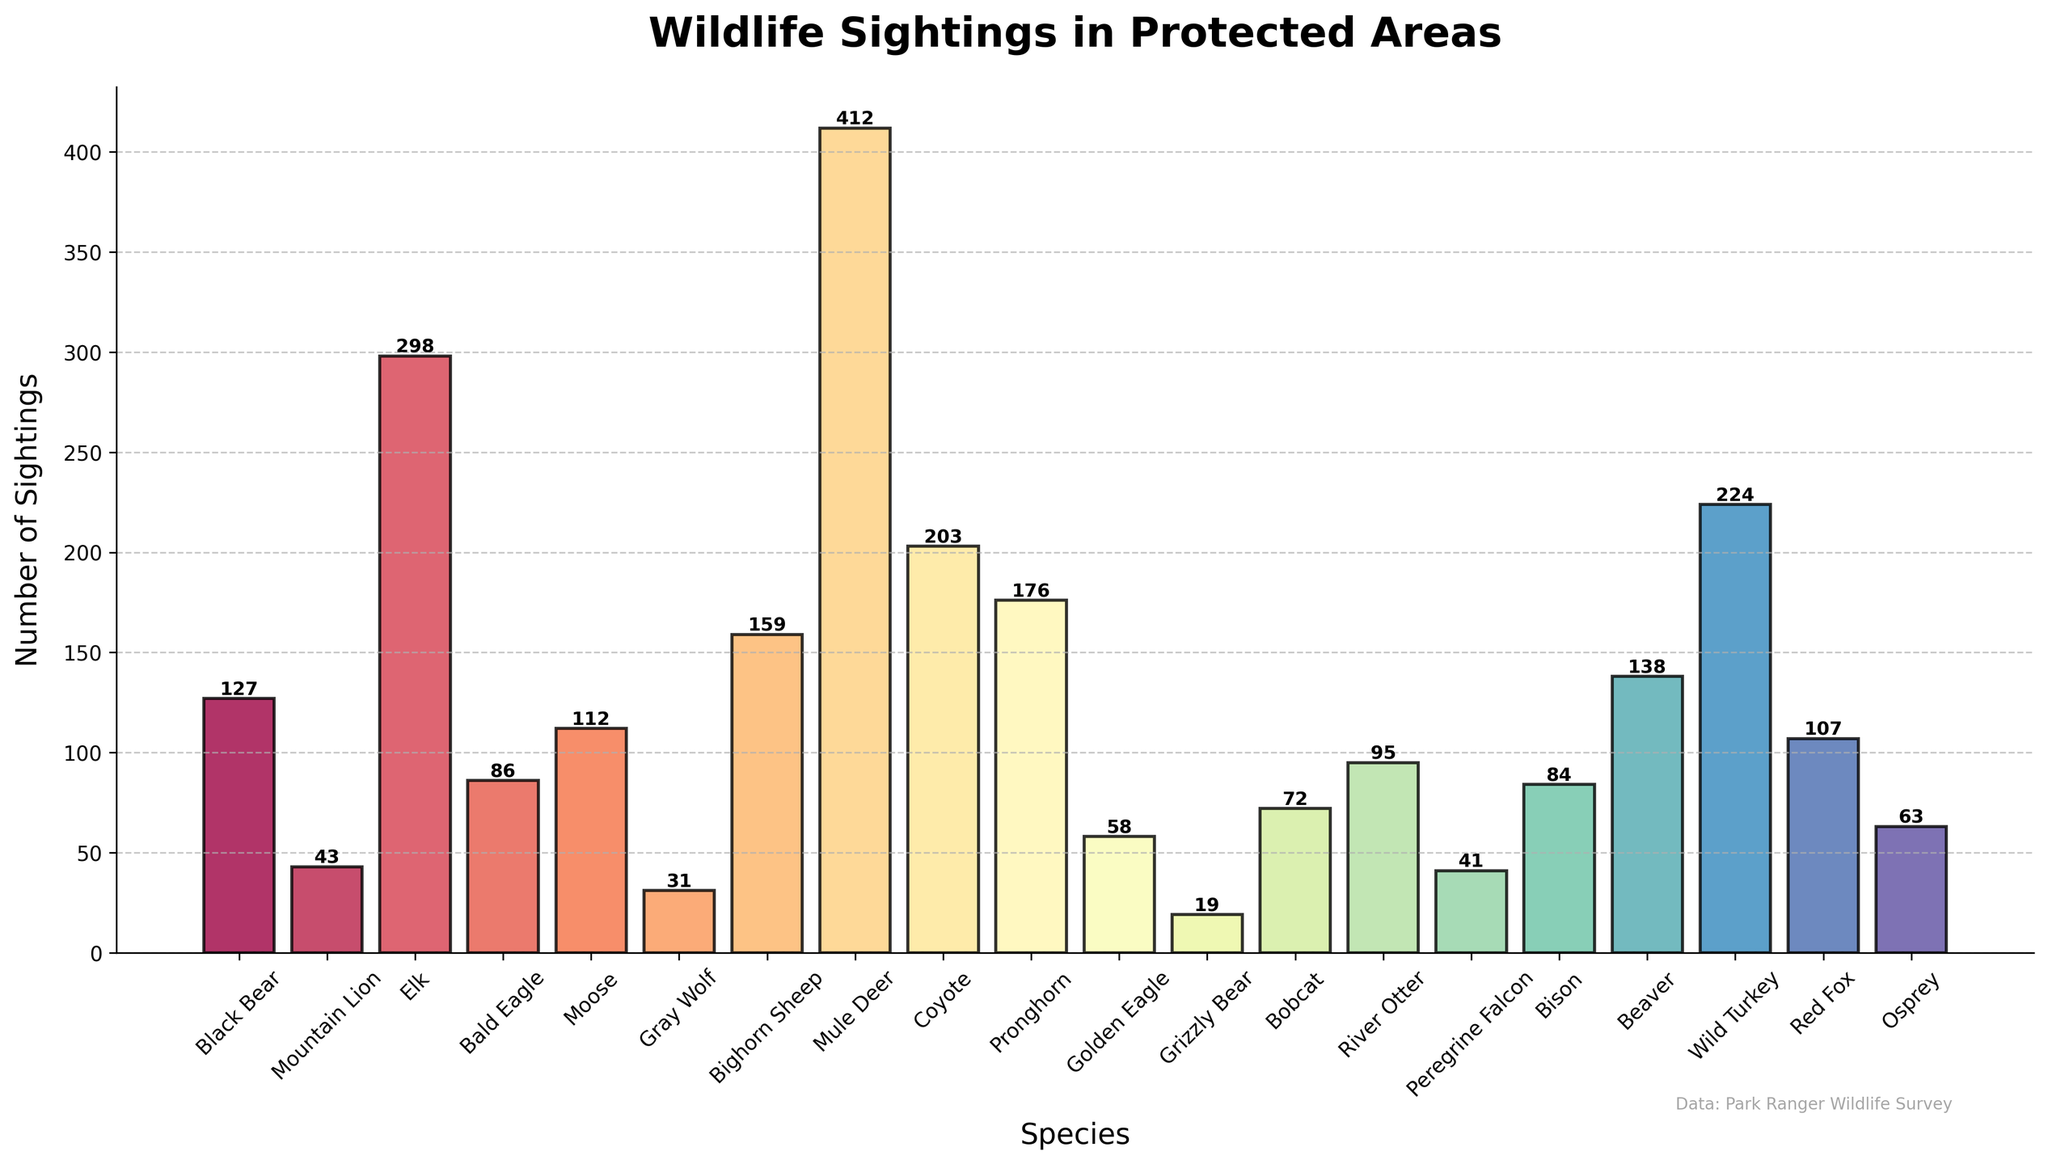Which species had the highest number of sightings? To determine the species with the highest number of sightings, identify the tallest bar in the chart and note the species associated with it. The tallest bar represents Mule Deer with 412 sightings
Answer: Mule Deer Which species had fewer sightings: Bald Eagle or Gray Wolf? Compare the height of the bars for Bald Eagle and Gray Wolf. The bar for Gray Wolf is shorter, indicating it had fewer sightings. Bald Eagle had 86 sightings, while Gray Wolf had 31 sightings
Answer: Gray Wolf What's the total number of sightings for Grizzly Bear, Bobcat, and River Otter combined? Locate the bars for Grizzly Bear, Bobcat, and River Otter, then sum their sightings. Grizzly Bear (19) + Bobcat (72) + River Otter (95) = 186
Answer: 186 Which species had a higher number of sightings than Osprey but fewer than Black Bear? Identify the species whose bar heights are greater than Osprey's 63 sightings and less than Black Bear's 127 sightings. The species that fit this criterion are Golden Eagle (58), Bobcat (72), Beaver (138), Red Fox (107), and River Otter (95)
Answer: Beaver, Bobcat, Red Fox, River Otter What is the difference in sightings between the most frequently and least frequently seen species? Find the species with the highest (Mule Deer, 412) and lowest (Grizzly Bear, 19) sightings, then compute the difference. 412 - 19 = 393
Answer: 393 Which species falls in the middle if you rank them based on the number of sightings from highest to lowest? List the species in descending order of sightings and find the middle one. The list is Mule Deer, Elk, Wild Turkey, Coyote, Pronghorn, Bighorn Sheep, Beaver, Black Bear, Red Fox, Moose, Bald Eagle, Bison, River Otter, Bobcat, Osprey, Peregrine Falcon, Mountain Lion, Golden Eagle, Gray Wolf, Grizzly Bear. The middle species is Bison
Answer: Bison How many species had sightings of more than 100 but fewer than 200? Count the bars with heights between 100 and 200. These species include Moose (112), Bighorn Sheep (159), Pronghorn (176), and Red Fox (107)
Answer: 4 What are the combined sightings of the two bird species with the highest sightings? Identify the bird species with the highest sightings: Bald Eagle (86) and Wild Turkey (224), then sum their sightings. 86 + 224 = 310
Answer: 310 Which species has a bar colored in the middle of the color spectrum? Look for the species whose bar color appears in the middle of the color gradient. This often corresponds to species roughly in the middle of the dataset. Given the color mapping, Moose or Bighorn Sheep likely fall in this range
Answer: Moose or Bighorn Sheep How many more sightings did Mule Deer have compared to Black Bear? Subtract the number of sightings of Black Bear from those of Mule Deer. 412 - 127 = 285
Answer: 285 